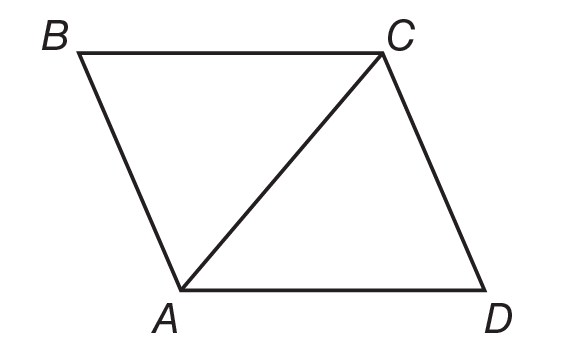Answer the mathemtical geometry problem and directly provide the correct option letter.
Question: Quadrilateral A B C D is a rhombus. If m \angle B C D = 120, find m \angle D A C.
Choices: A: 30 B: 60 C: 90 D: 120 B 